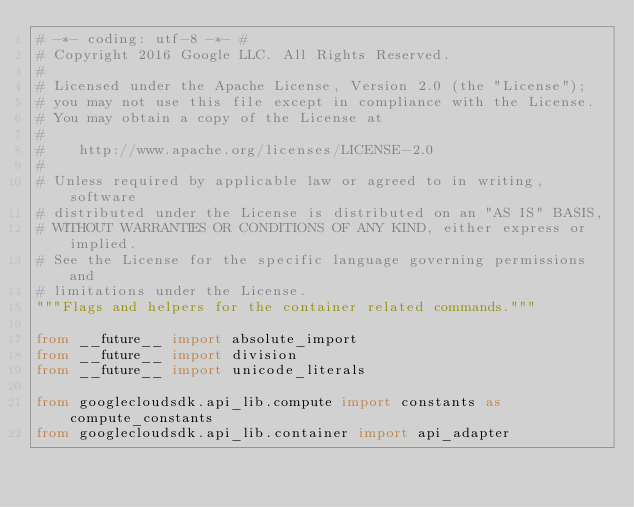<code> <loc_0><loc_0><loc_500><loc_500><_Python_># -*- coding: utf-8 -*- #
# Copyright 2016 Google LLC. All Rights Reserved.
#
# Licensed under the Apache License, Version 2.0 (the "License");
# you may not use this file except in compliance with the License.
# You may obtain a copy of the License at
#
#    http://www.apache.org/licenses/LICENSE-2.0
#
# Unless required by applicable law or agreed to in writing, software
# distributed under the License is distributed on an "AS IS" BASIS,
# WITHOUT WARRANTIES OR CONDITIONS OF ANY KIND, either express or implied.
# See the License for the specific language governing permissions and
# limitations under the License.
"""Flags and helpers for the container related commands."""

from __future__ import absolute_import
from __future__ import division
from __future__ import unicode_literals

from googlecloudsdk.api_lib.compute import constants as compute_constants
from googlecloudsdk.api_lib.container import api_adapter</code> 